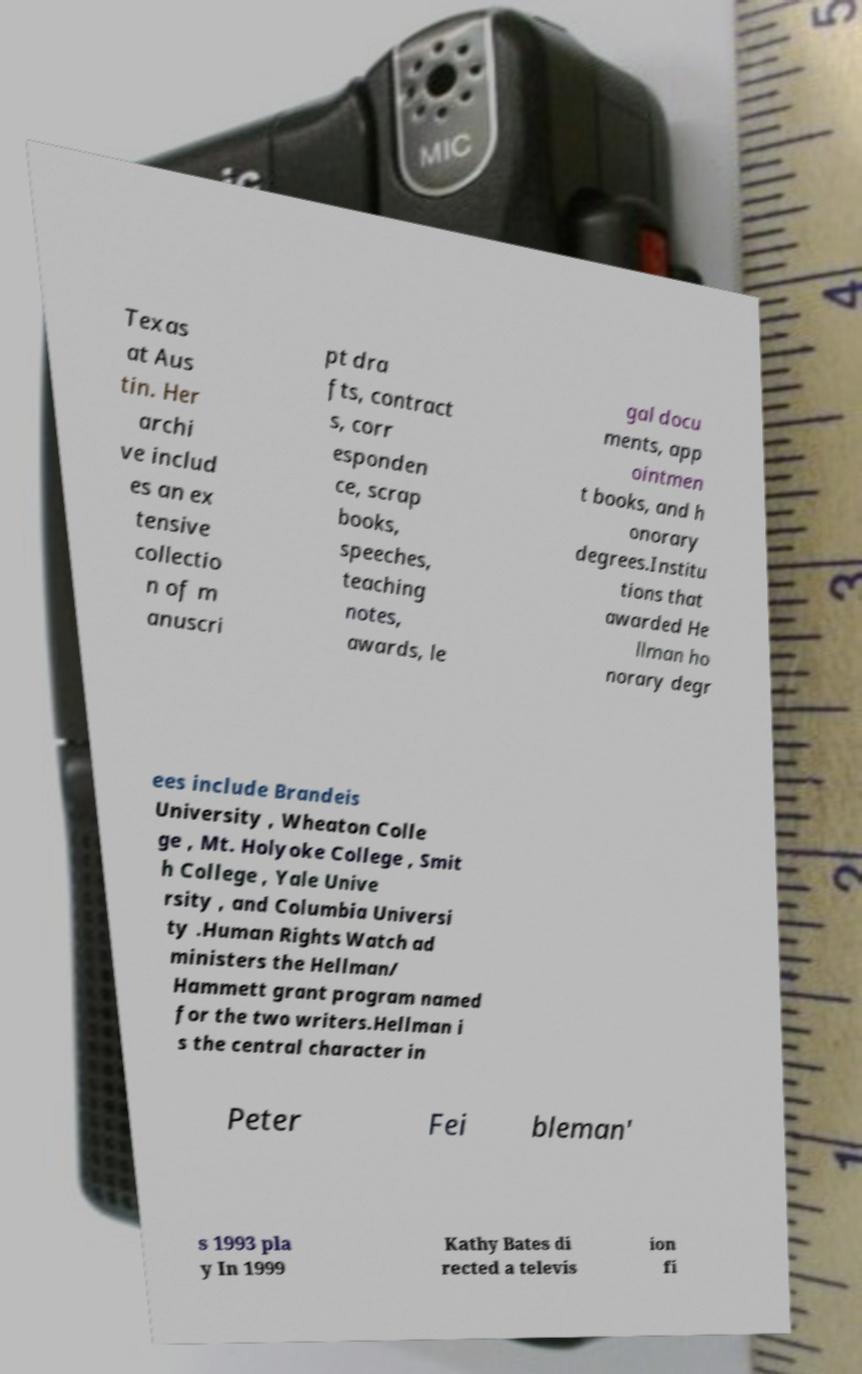Please identify and transcribe the text found in this image. Texas at Aus tin. Her archi ve includ es an ex tensive collectio n of m anuscri pt dra fts, contract s, corr esponden ce, scrap books, speeches, teaching notes, awards, le gal docu ments, app ointmen t books, and h onorary degrees.Institu tions that awarded He llman ho norary degr ees include Brandeis University , Wheaton Colle ge , Mt. Holyoke College , Smit h College , Yale Unive rsity , and Columbia Universi ty .Human Rights Watch ad ministers the Hellman/ Hammett grant program named for the two writers.Hellman i s the central character in Peter Fei bleman' s 1993 pla y In 1999 Kathy Bates di rected a televis ion fi 